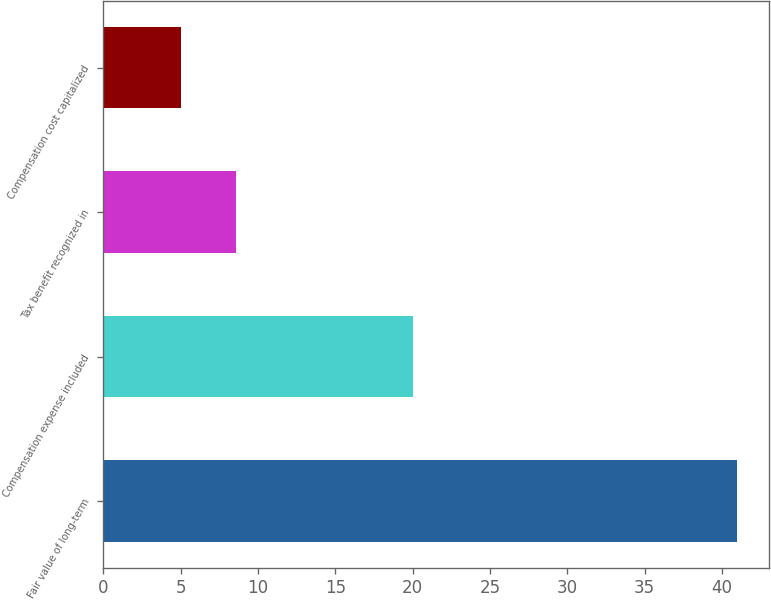Convert chart to OTSL. <chart><loc_0><loc_0><loc_500><loc_500><bar_chart><fcel>Fair value of long-term<fcel>Compensation expense included<fcel>Tax benefit recognized in<fcel>Compensation cost capitalized<nl><fcel>41<fcel>20<fcel>8.6<fcel>5<nl></chart> 